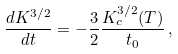Convert formula to latex. <formula><loc_0><loc_0><loc_500><loc_500>\frac { d K ^ { 3 / 2 } } { d t } = - \frac { 3 } { 2 } \frac { K _ { c } ^ { 3 / 2 } ( T ) } { t _ { 0 } } \, ,</formula> 